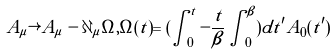Convert formula to latex. <formula><loc_0><loc_0><loc_500><loc_500>A _ { \mu } \rightarrow A _ { \mu } - \partial _ { \mu } \Omega , \Omega ( t ) = ( \int _ { 0 } ^ { t } - \frac { t } { \beta } \int _ { 0 } ^ { \beta } ) d t ^ { \prime } A _ { 0 } ( t ^ { \prime } )</formula> 